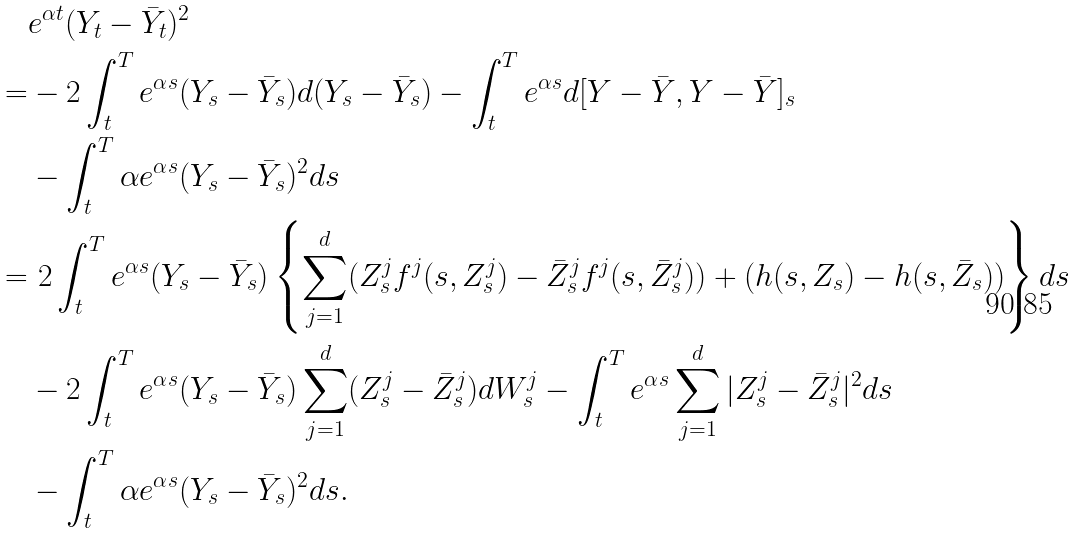<formula> <loc_0><loc_0><loc_500><loc_500>& e ^ { \alpha t } ( Y _ { t } - \bar { Y } _ { t } ) ^ { 2 } \\ = & - 2 \int _ { t } ^ { T } e ^ { \alpha s } ( Y _ { s } - \bar { Y } _ { s } ) d ( Y _ { s } - \bar { Y } _ { s } ) - \int _ { t } ^ { T } e ^ { \alpha s } d [ Y - \bar { Y } , Y - \bar { Y } ] _ { s } \\ & - \int _ { t } ^ { T } \alpha e ^ { \alpha s } ( Y _ { s } - \bar { Y } _ { s } ) ^ { 2 } d s \\ = & \ 2 \int _ { t } ^ { T } e ^ { \alpha s } ( Y _ { s } - \bar { Y } _ { s } ) \left \{ \sum _ { j = 1 } ^ { d } ( Z ^ { j } _ { s } f ^ { j } ( s , Z ^ { j } _ { s } ) - \bar { Z } ^ { j } _ { s } f ^ { j } ( s , \bar { Z } ^ { j } _ { s } ) ) + ( h ( s , Z _ { s } ) - h ( s , \bar { Z } _ { s } ) ) \right \} d s \\ & - 2 \int _ { t } ^ { T } e ^ { \alpha s } ( Y _ { s } - \bar { Y } _ { s } ) \sum _ { j = 1 } ^ { d } ( Z ^ { j } _ { s } - \bar { Z } ^ { j } _ { s } ) d W _ { s } ^ { j } - \int _ { t } ^ { T } e ^ { \alpha s } \sum _ { j = 1 } ^ { d } | Z _ { s } ^ { j } - \bar { Z } _ { s } ^ { j } | ^ { 2 } d s \\ & - \int _ { t } ^ { T } \alpha e ^ { \alpha s } ( Y _ { s } - \bar { Y } _ { s } ) ^ { 2 } d s .</formula> 